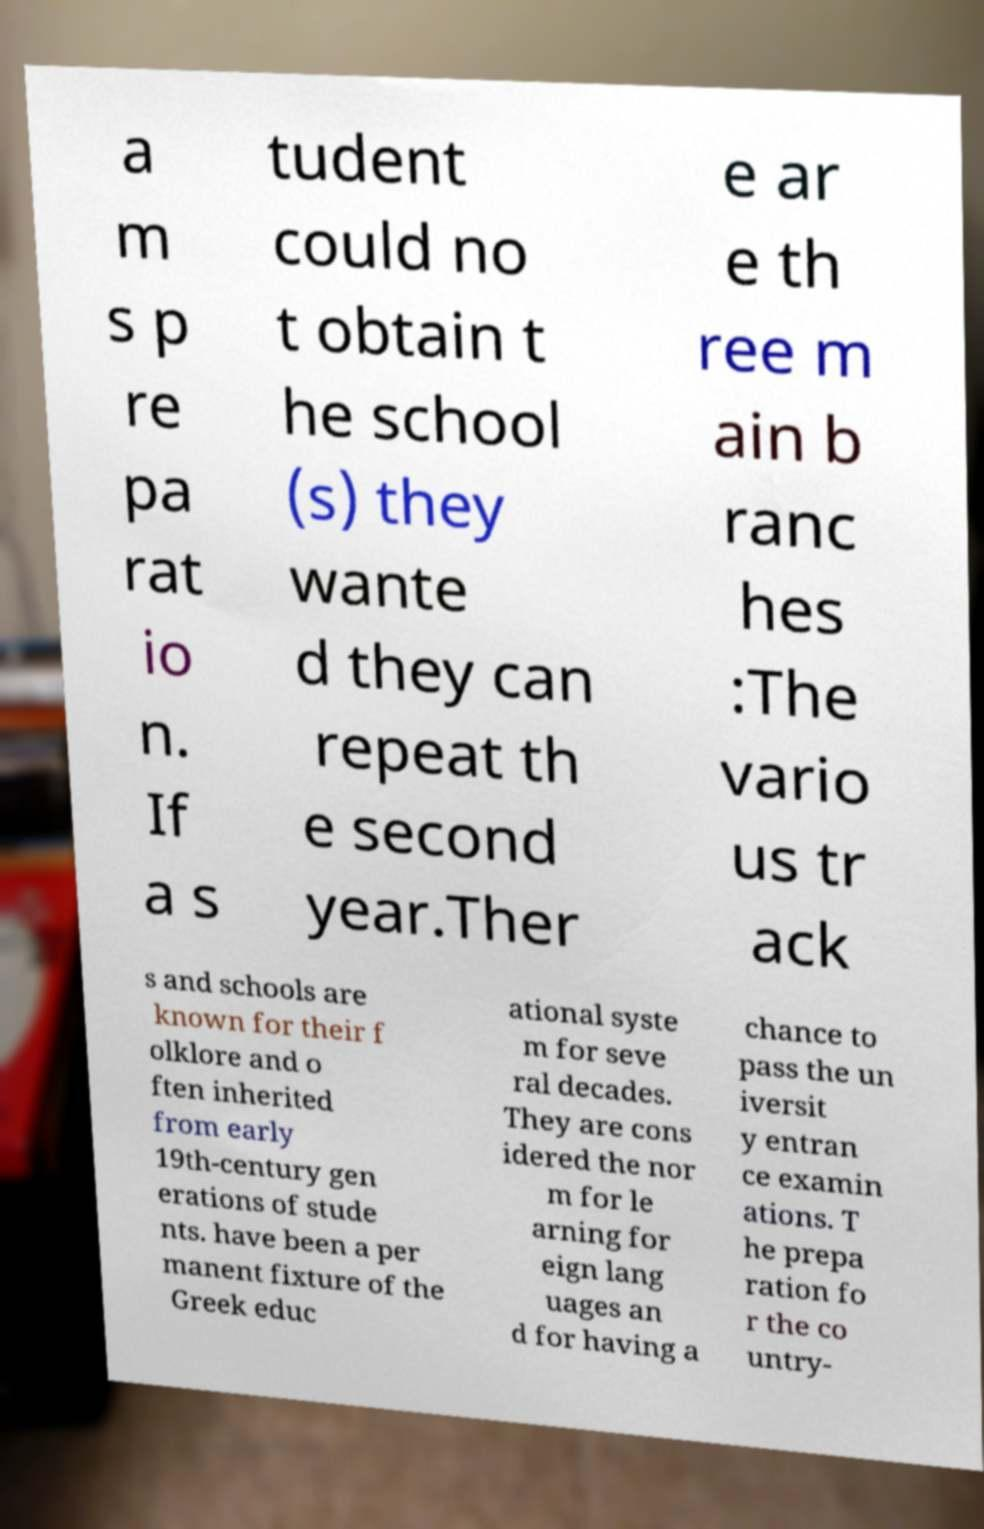I need the written content from this picture converted into text. Can you do that? a m s p re pa rat io n. If a s tudent could no t obtain t he school (s) they wante d they can repeat th e second year.Ther e ar e th ree m ain b ranc hes :The vario us tr ack s and schools are known for their f olklore and o ften inherited from early 19th-century gen erations of stude nts. have been a per manent fixture of the Greek educ ational syste m for seve ral decades. They are cons idered the nor m for le arning for eign lang uages an d for having a chance to pass the un iversit y entran ce examin ations. T he prepa ration fo r the co untry- 